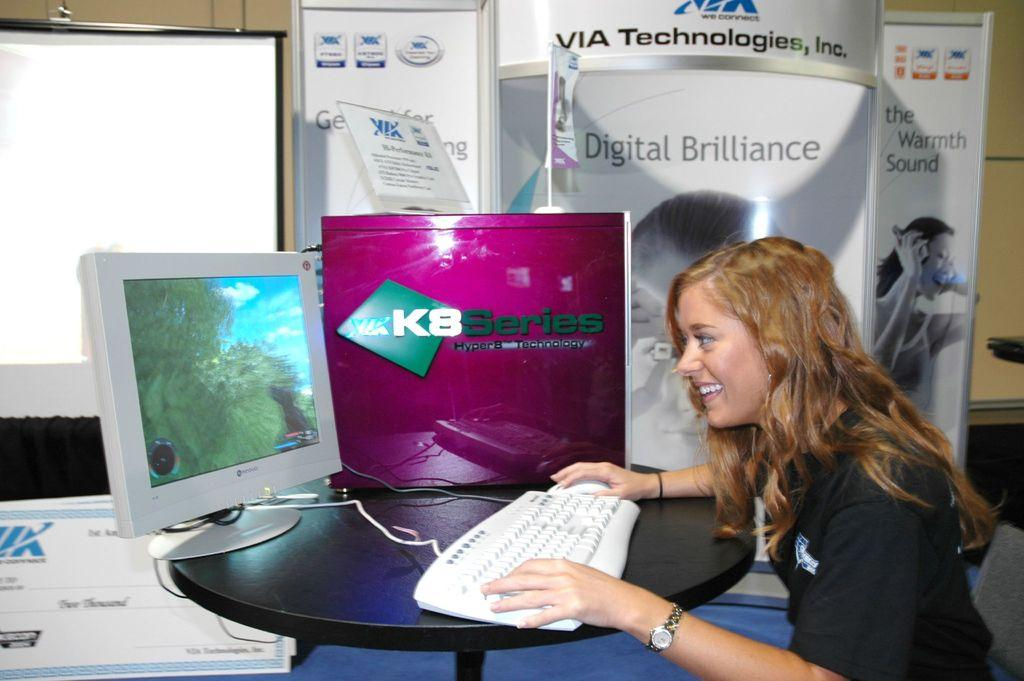<image>
Provide a brief description of the given image. A long-haired woman sits in front of a computer with a screen that says KB Series. 